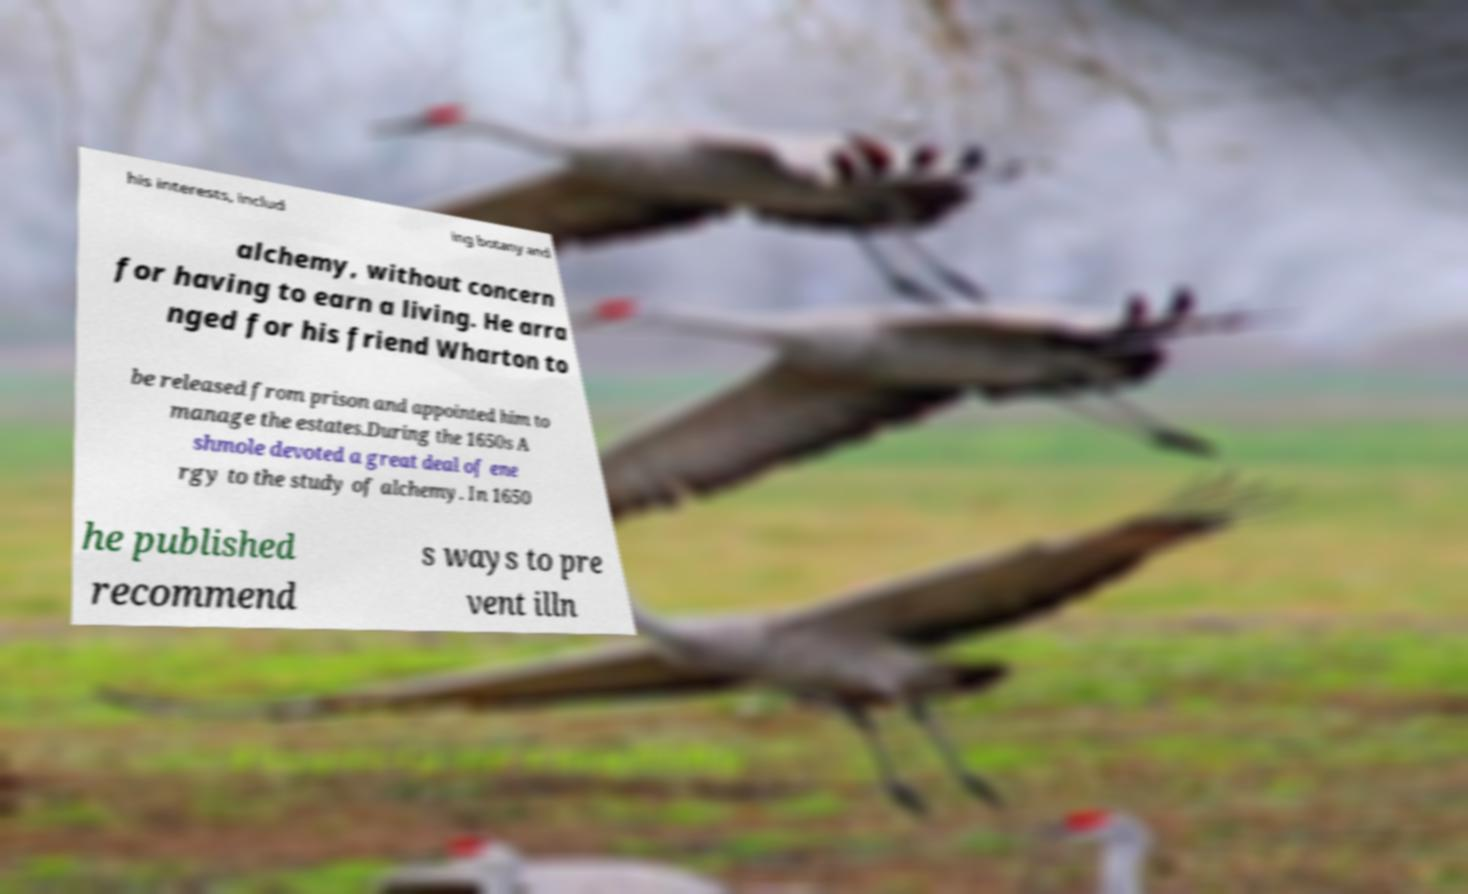Could you assist in decoding the text presented in this image and type it out clearly? his interests, includ ing botany and alchemy, without concern for having to earn a living. He arra nged for his friend Wharton to be released from prison and appointed him to manage the estates.During the 1650s A shmole devoted a great deal of ene rgy to the study of alchemy. In 1650 he published recommend s ways to pre vent illn 